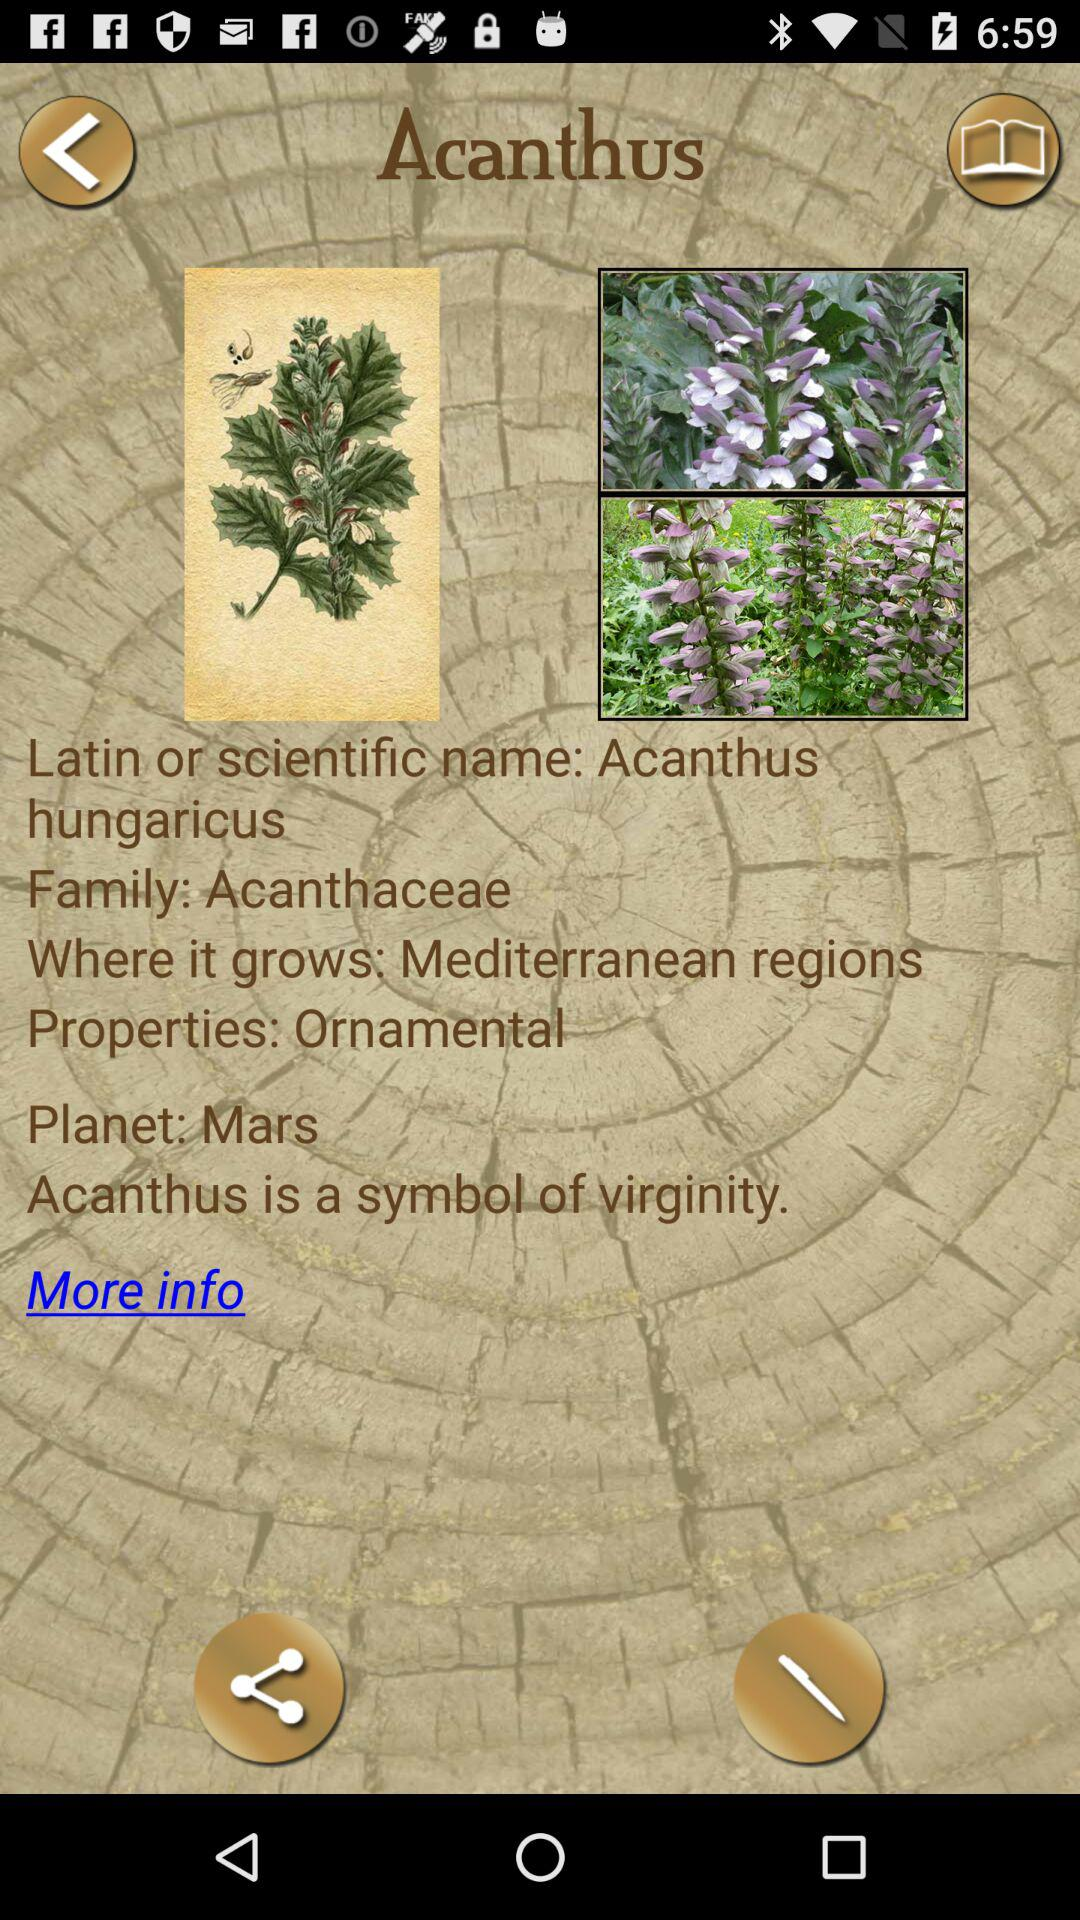What properties does Acanthus have? The property of Acanthus is "Ornamental". 